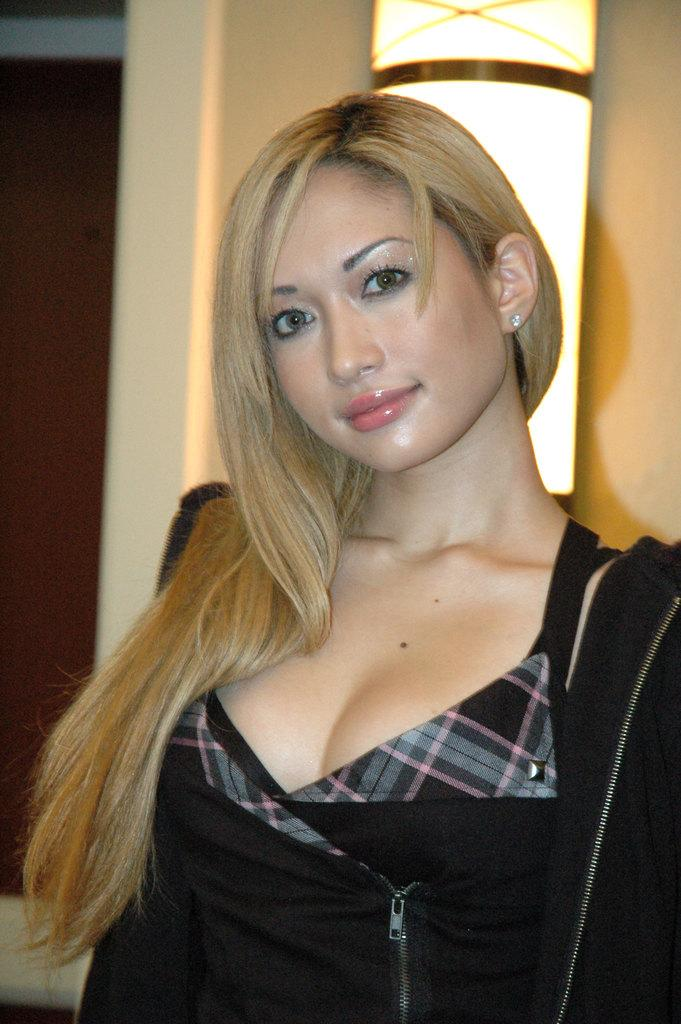What is the main subject of the image? The main subject of the image is a woman. What is the woman doing in the image? The woman is smiling in the image. Can you describe the lighting in the image? There is a light visible behind the woman in the image. How many hands does the woman have in the image? The number of hands the woman has cannot be determined from the image, as it only shows her from the shoulders up. What type of good-bye gesture is the woman making in the image? There is no good-bye gesture visible in the image; the woman is simply smiling. What is the shape of the woman's chin in the image? The shape of the woman's chin cannot be determined from the image, as it only shows her from the shoulders up. 